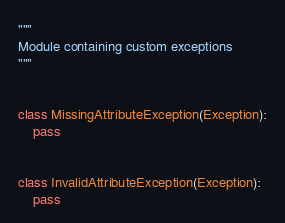Convert code to text. <code><loc_0><loc_0><loc_500><loc_500><_Python_>"""
Module containing custom exceptions
"""


class MissingAttributeException(Exception):
    pass


class InvalidAttributeException(Exception):
    pass
</code> 